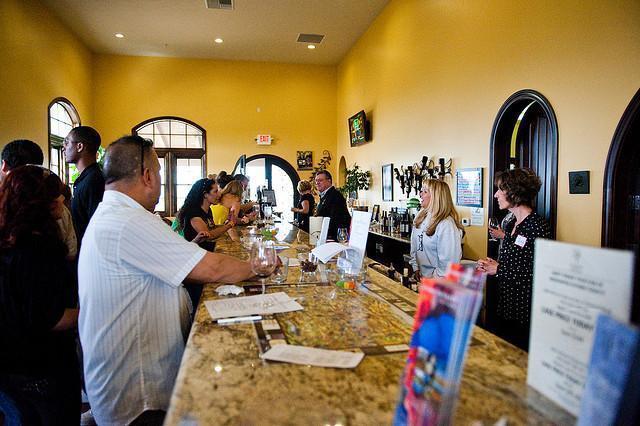How many women are behind the bar?
Give a very brief answer. 3. How many people can be seen?
Give a very brief answer. 6. How many light color cars are there?
Give a very brief answer. 0. 